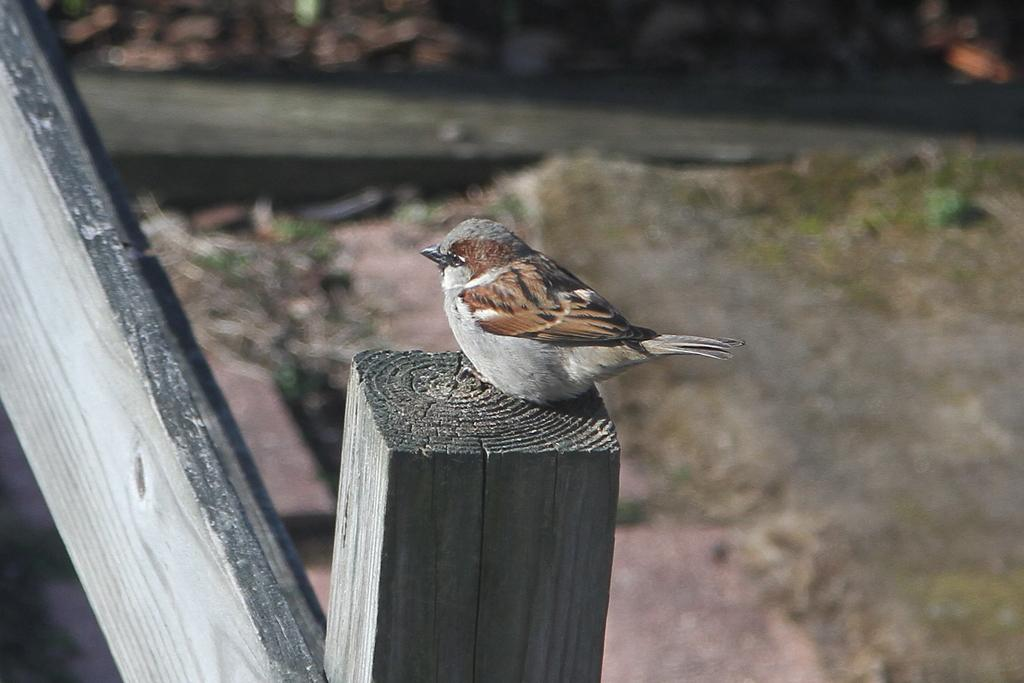What type of bird is in the image? There is a sparrow in the image. What is the sparrow standing on? The sparrow is on a wooden surface. Can you describe the background of the image? The background of the image is blurred. How many babies are visible in the image? There are no babies present in the image; it features a sparrow on a wooden surface with a blurred background. What type of work is the sparrow doing in the image? The image does not depict the sparrow performing any work or task. 